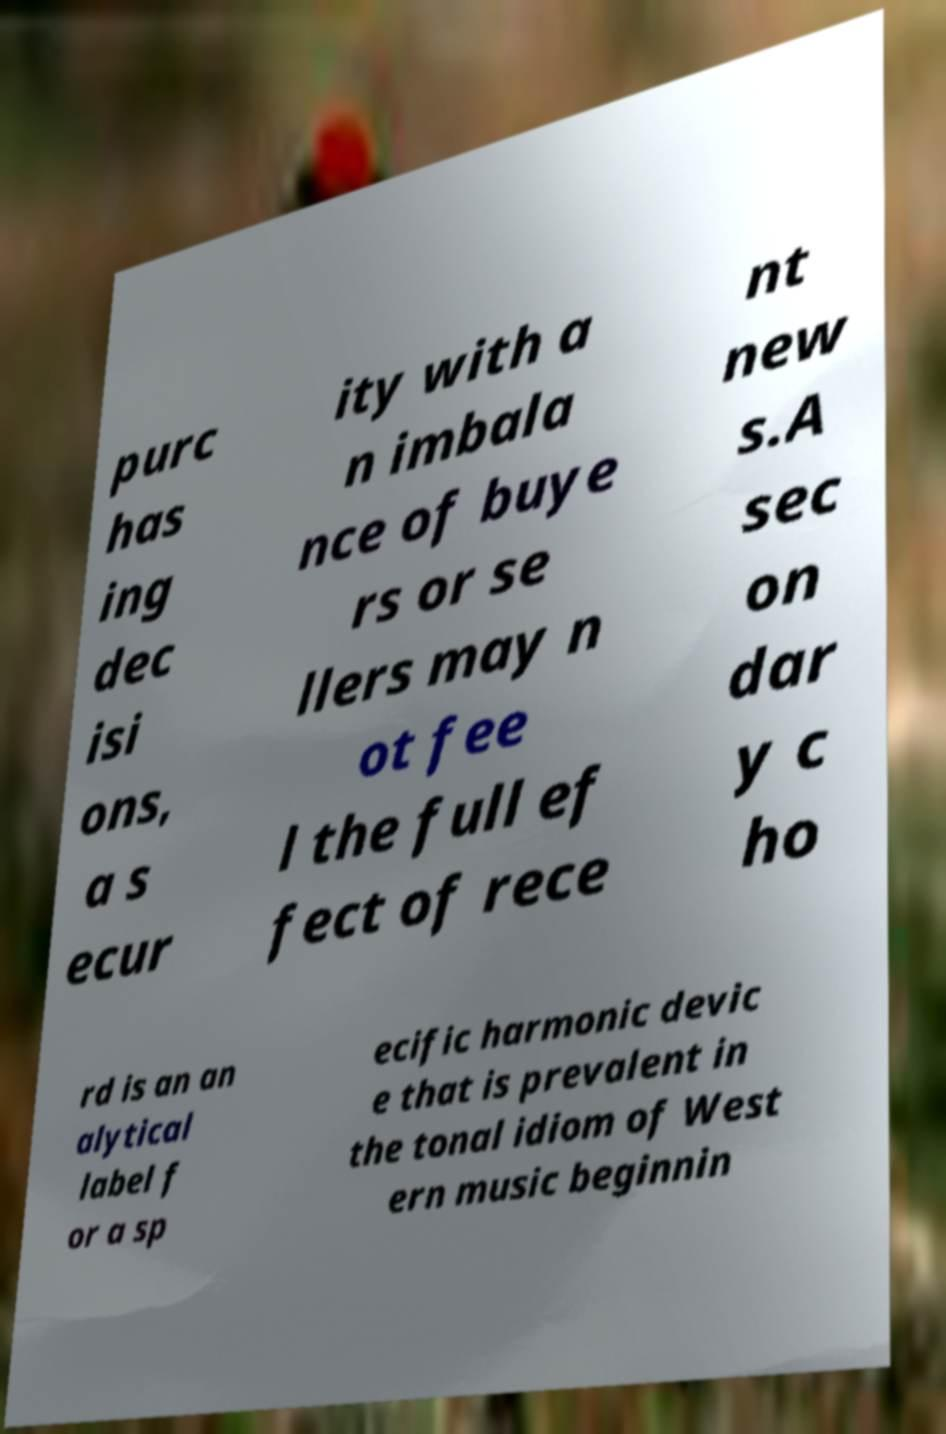Can you read and provide the text displayed in the image?This photo seems to have some interesting text. Can you extract and type it out for me? purc has ing dec isi ons, a s ecur ity with a n imbala nce of buye rs or se llers may n ot fee l the full ef fect of rece nt new s.A sec on dar y c ho rd is an an alytical label f or a sp ecific harmonic devic e that is prevalent in the tonal idiom of West ern music beginnin 